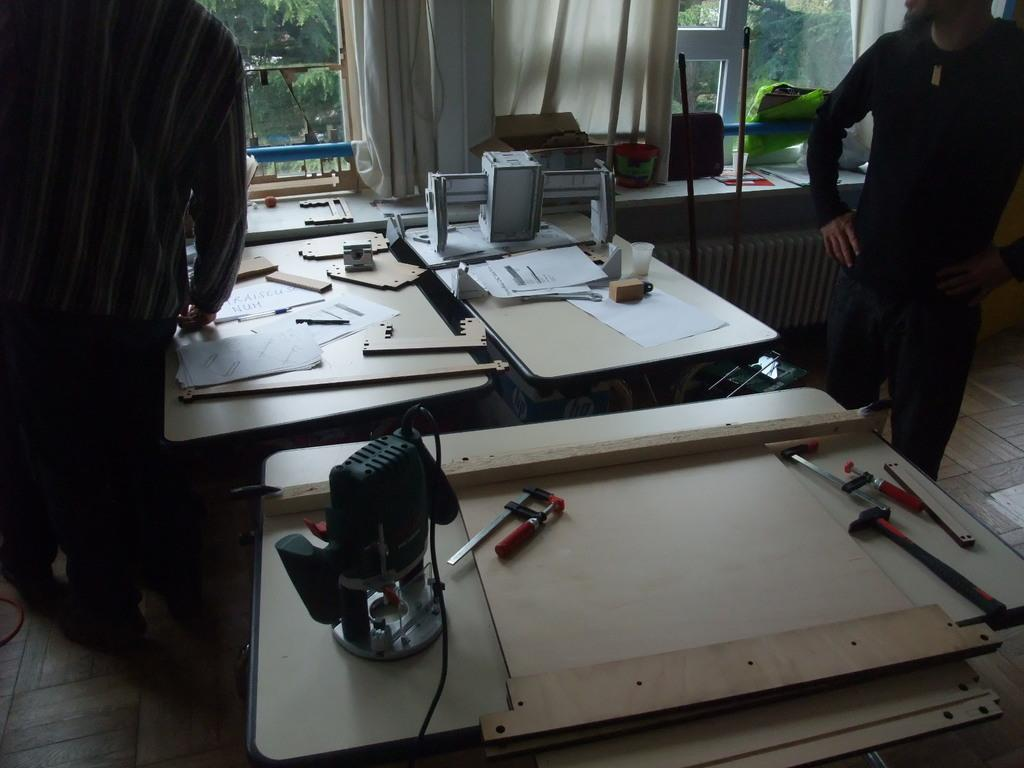How many people are in the image? There are two persons standing in the image. What are the people wearing? The persons are wearing colorful clothes. How many tables are visible in the image? There are three tables in the image. What can be found on the tables? The tables contain machines, tools, and papers. What is present near the window? The window has curtains. What type of mass is being held in the image? There is no indication of a mass or gathering in the image; it features two people, tables, and a window with curtains. 